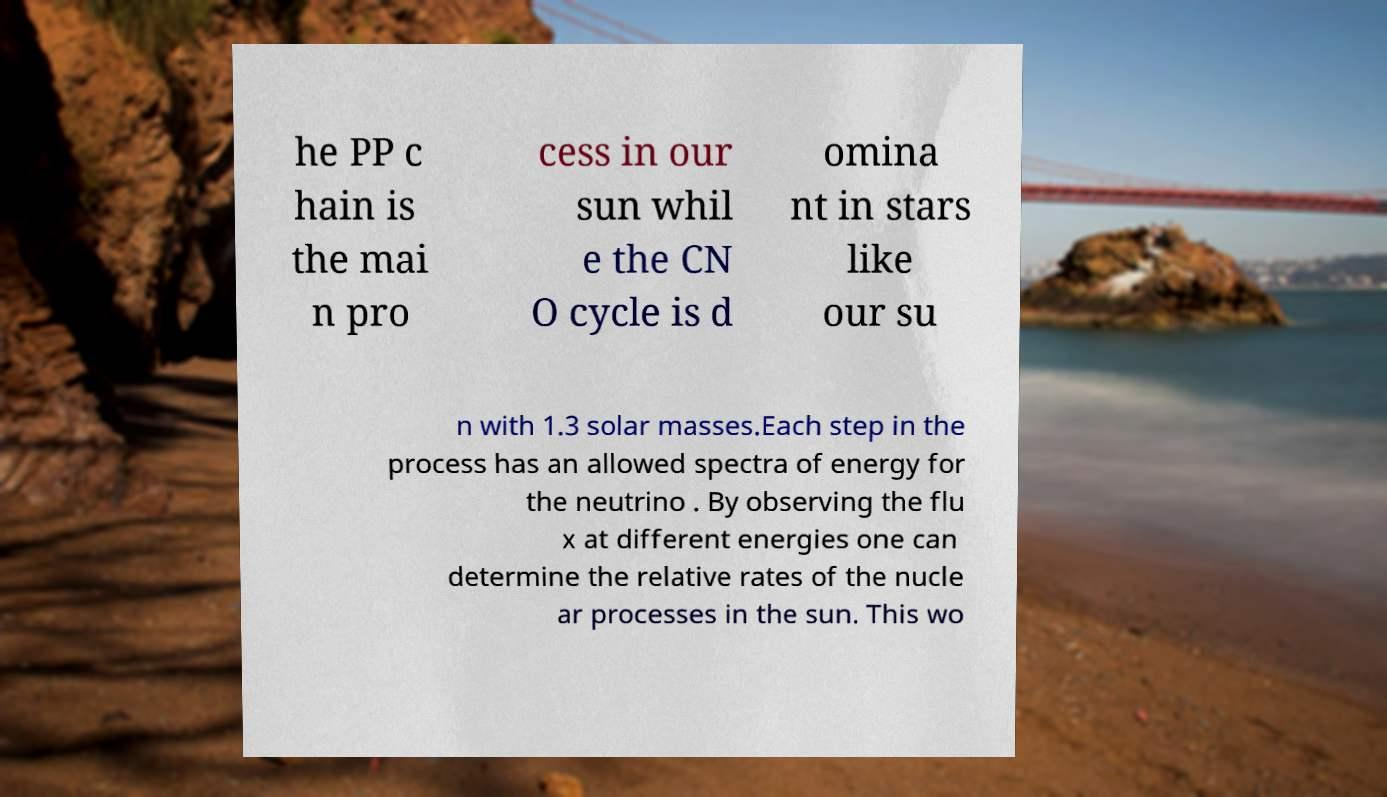I need the written content from this picture converted into text. Can you do that? he PP c hain is the mai n pro cess in our sun whil e the CN O cycle is d omina nt in stars like our su n with 1.3 solar masses.Each step in the process has an allowed spectra of energy for the neutrino . By observing the flu x at different energies one can determine the relative rates of the nucle ar processes in the sun. This wo 